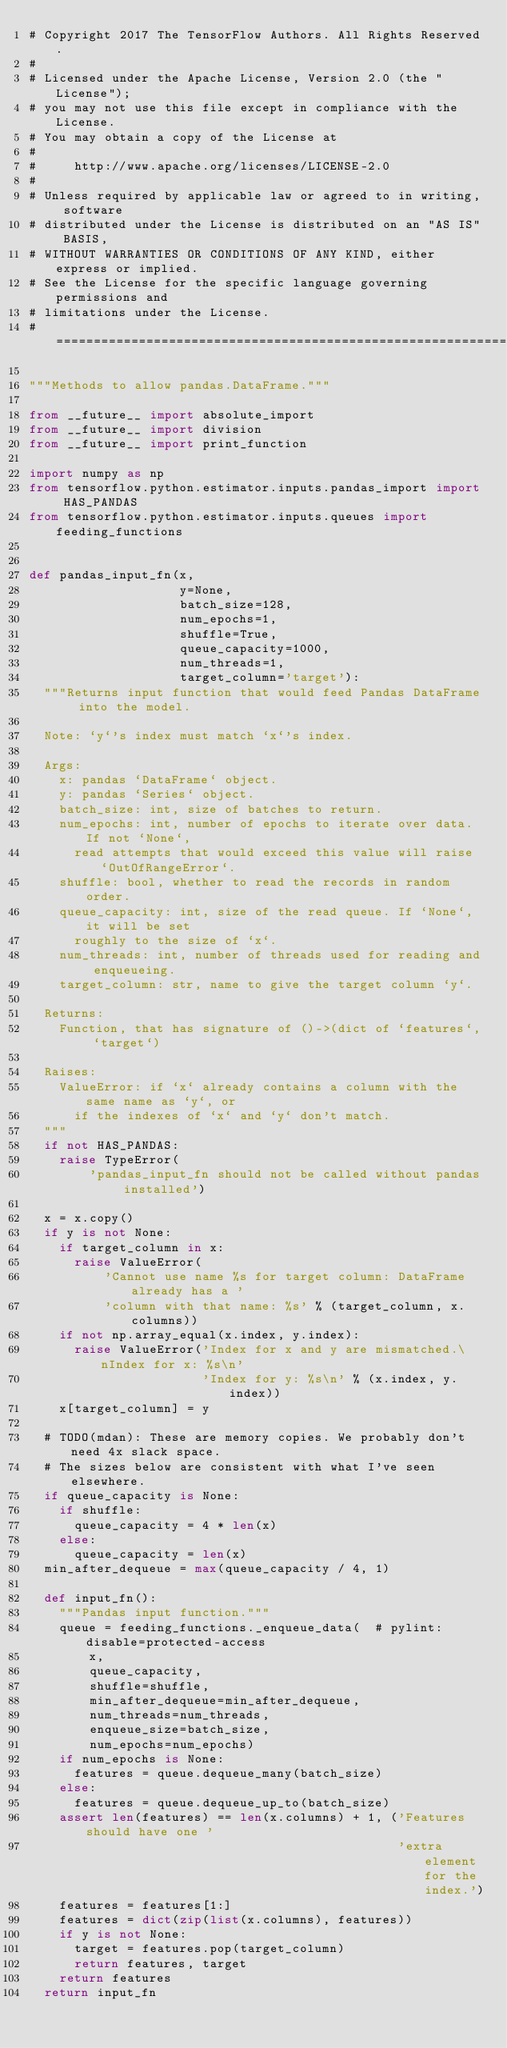<code> <loc_0><loc_0><loc_500><loc_500><_Python_># Copyright 2017 The TensorFlow Authors. All Rights Reserved.
#
# Licensed under the Apache License, Version 2.0 (the "License");
# you may not use this file except in compliance with the License.
# You may obtain a copy of the License at
#
#     http://www.apache.org/licenses/LICENSE-2.0
#
# Unless required by applicable law or agreed to in writing, software
# distributed under the License is distributed on an "AS IS" BASIS,
# WITHOUT WARRANTIES OR CONDITIONS OF ANY KIND, either express or implied.
# See the License for the specific language governing permissions and
# limitations under the License.
# ==============================================================================

"""Methods to allow pandas.DataFrame."""

from __future__ import absolute_import
from __future__ import division
from __future__ import print_function

import numpy as np
from tensorflow.python.estimator.inputs.pandas_import import HAS_PANDAS
from tensorflow.python.estimator.inputs.queues import feeding_functions


def pandas_input_fn(x,
                    y=None,
                    batch_size=128,
                    num_epochs=1,
                    shuffle=True,
                    queue_capacity=1000,
                    num_threads=1,
                    target_column='target'):
  """Returns input function that would feed Pandas DataFrame into the model.

  Note: `y`'s index must match `x`'s index.

  Args:
    x: pandas `DataFrame` object.
    y: pandas `Series` object.
    batch_size: int, size of batches to return.
    num_epochs: int, number of epochs to iterate over data. If not `None`,
      read attempts that would exceed this value will raise `OutOfRangeError`.
    shuffle: bool, whether to read the records in random order.
    queue_capacity: int, size of the read queue. If `None`, it will be set
      roughly to the size of `x`.
    num_threads: int, number of threads used for reading and enqueueing.
    target_column: str, name to give the target column `y`.

  Returns:
    Function, that has signature of ()->(dict of `features`, `target`)

  Raises:
    ValueError: if `x` already contains a column with the same name as `y`, or
      if the indexes of `x` and `y` don't match.
  """
  if not HAS_PANDAS:
    raise TypeError(
        'pandas_input_fn should not be called without pandas installed')

  x = x.copy()
  if y is not None:
    if target_column in x:
      raise ValueError(
          'Cannot use name %s for target column: DataFrame already has a '
          'column with that name: %s' % (target_column, x.columns))
    if not np.array_equal(x.index, y.index):
      raise ValueError('Index for x and y are mismatched.\nIndex for x: %s\n'
                       'Index for y: %s\n' % (x.index, y.index))
    x[target_column] = y

  # TODO(mdan): These are memory copies. We probably don't need 4x slack space.
  # The sizes below are consistent with what I've seen elsewhere.
  if queue_capacity is None:
    if shuffle:
      queue_capacity = 4 * len(x)
    else:
      queue_capacity = len(x)
  min_after_dequeue = max(queue_capacity / 4, 1)

  def input_fn():
    """Pandas input function."""
    queue = feeding_functions._enqueue_data(  # pylint: disable=protected-access
        x,
        queue_capacity,
        shuffle=shuffle,
        min_after_dequeue=min_after_dequeue,
        num_threads=num_threads,
        enqueue_size=batch_size,
        num_epochs=num_epochs)
    if num_epochs is None:
      features = queue.dequeue_many(batch_size)
    else:
      features = queue.dequeue_up_to(batch_size)
    assert len(features) == len(x.columns) + 1, ('Features should have one '
                                                 'extra element for the index.')
    features = features[1:]
    features = dict(zip(list(x.columns), features))
    if y is not None:
      target = features.pop(target_column)
      return features, target
    return features
  return input_fn
</code> 